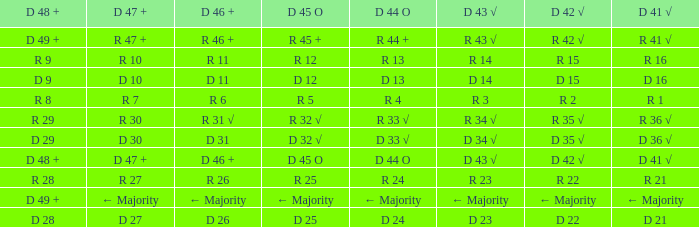What is the value of D 46 +, when the value of D 42 √ is r 2? R 6. 